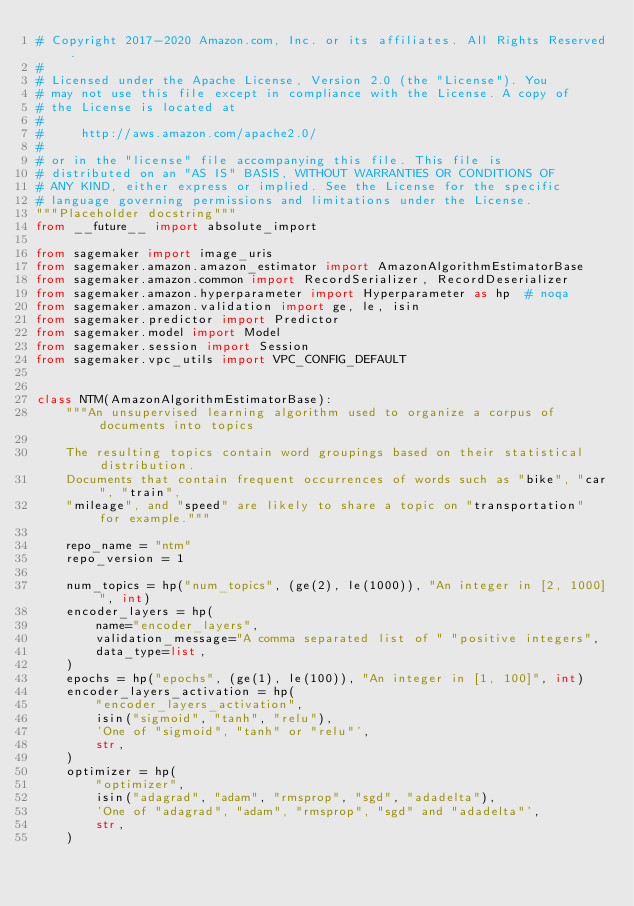Convert code to text. <code><loc_0><loc_0><loc_500><loc_500><_Python_># Copyright 2017-2020 Amazon.com, Inc. or its affiliates. All Rights Reserved.
#
# Licensed under the Apache License, Version 2.0 (the "License"). You
# may not use this file except in compliance with the License. A copy of
# the License is located at
#
#     http://aws.amazon.com/apache2.0/
#
# or in the "license" file accompanying this file. This file is
# distributed on an "AS IS" BASIS, WITHOUT WARRANTIES OR CONDITIONS OF
# ANY KIND, either express or implied. See the License for the specific
# language governing permissions and limitations under the License.
"""Placeholder docstring"""
from __future__ import absolute_import

from sagemaker import image_uris
from sagemaker.amazon.amazon_estimator import AmazonAlgorithmEstimatorBase
from sagemaker.amazon.common import RecordSerializer, RecordDeserializer
from sagemaker.amazon.hyperparameter import Hyperparameter as hp  # noqa
from sagemaker.amazon.validation import ge, le, isin
from sagemaker.predictor import Predictor
from sagemaker.model import Model
from sagemaker.session import Session
from sagemaker.vpc_utils import VPC_CONFIG_DEFAULT


class NTM(AmazonAlgorithmEstimatorBase):
    """An unsupervised learning algorithm used to organize a corpus of documents into topics

    The resulting topics contain word groupings based on their statistical distribution.
    Documents that contain frequent occurrences of words such as "bike", "car", "train",
    "mileage", and "speed" are likely to share a topic on "transportation" for example."""

    repo_name = "ntm"
    repo_version = 1

    num_topics = hp("num_topics", (ge(2), le(1000)), "An integer in [2, 1000]", int)
    encoder_layers = hp(
        name="encoder_layers",
        validation_message="A comma separated list of " "positive integers",
        data_type=list,
    )
    epochs = hp("epochs", (ge(1), le(100)), "An integer in [1, 100]", int)
    encoder_layers_activation = hp(
        "encoder_layers_activation",
        isin("sigmoid", "tanh", "relu"),
        'One of "sigmoid", "tanh" or "relu"',
        str,
    )
    optimizer = hp(
        "optimizer",
        isin("adagrad", "adam", "rmsprop", "sgd", "adadelta"),
        'One of "adagrad", "adam", "rmsprop", "sgd" and "adadelta"',
        str,
    )</code> 